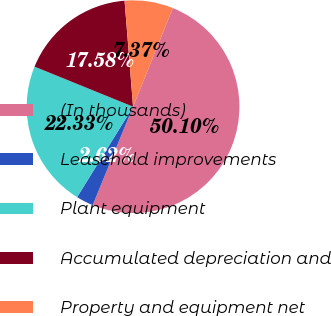Convert chart. <chart><loc_0><loc_0><loc_500><loc_500><pie_chart><fcel>(In thousands)<fcel>Leasehold improvements<fcel>Plant equipment<fcel>Accumulated depreciation and<fcel>Property and equipment net<nl><fcel>50.1%<fcel>2.62%<fcel>22.33%<fcel>17.58%<fcel>7.37%<nl></chart> 